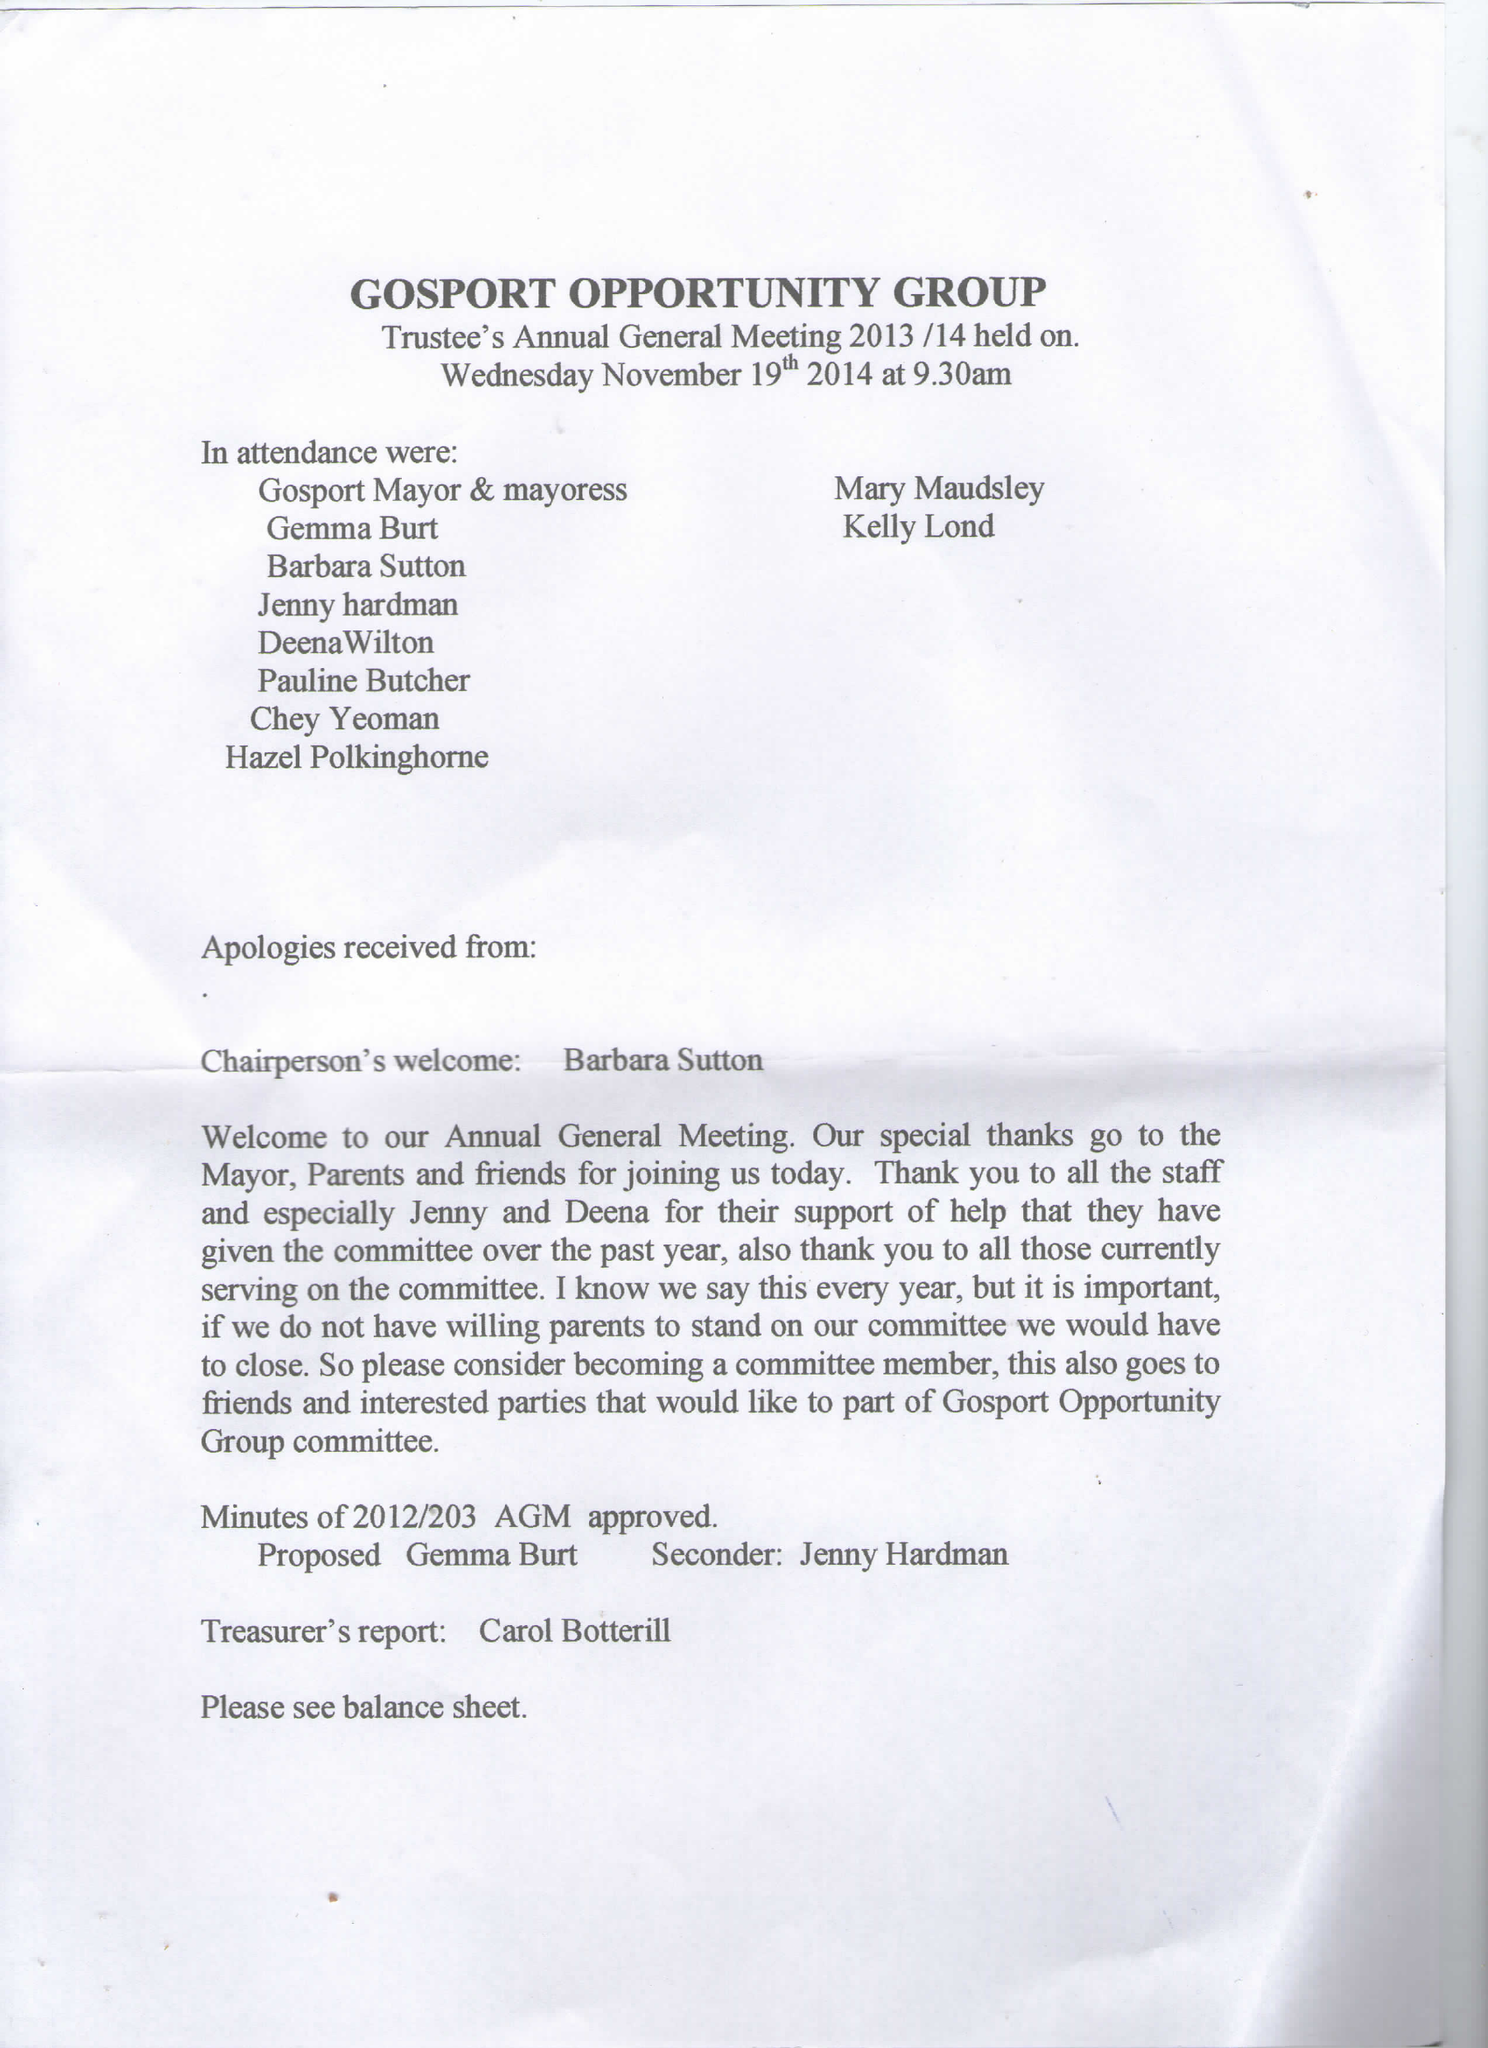What is the value for the address__street_line?
Answer the question using a single word or phrase. 1 PHOENIX WAY 